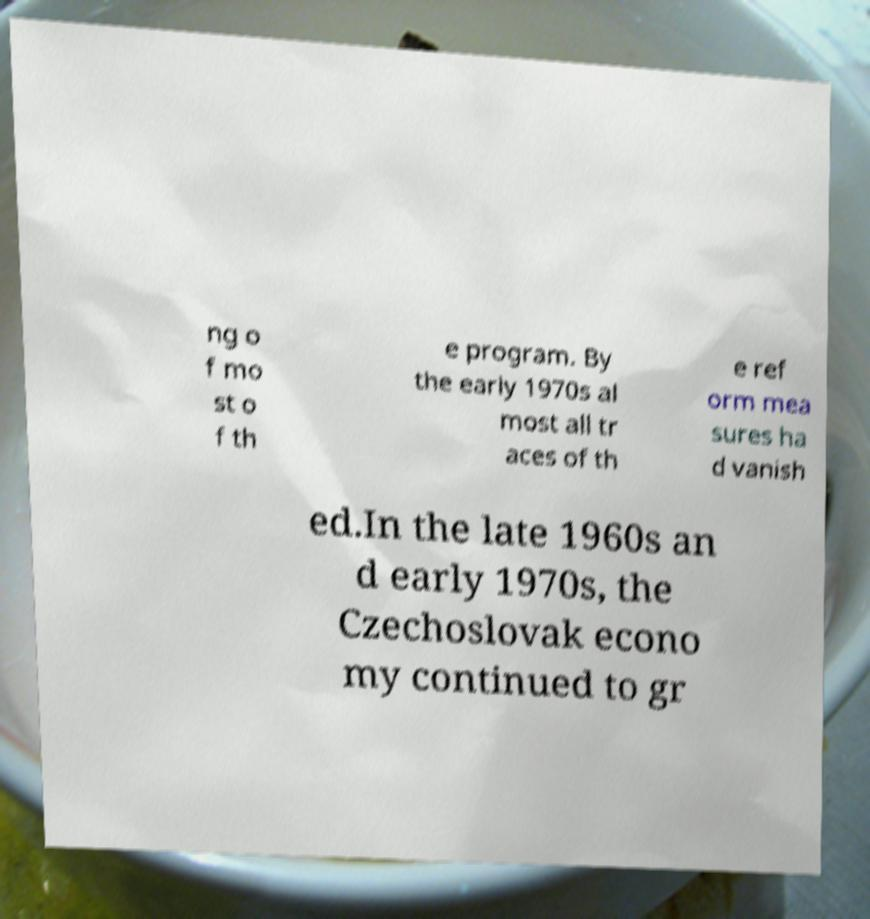I need the written content from this picture converted into text. Can you do that? ng o f mo st o f th e program. By the early 1970s al most all tr aces of th e ref orm mea sures ha d vanish ed.In the late 1960s an d early 1970s, the Czechoslovak econo my continued to gr 